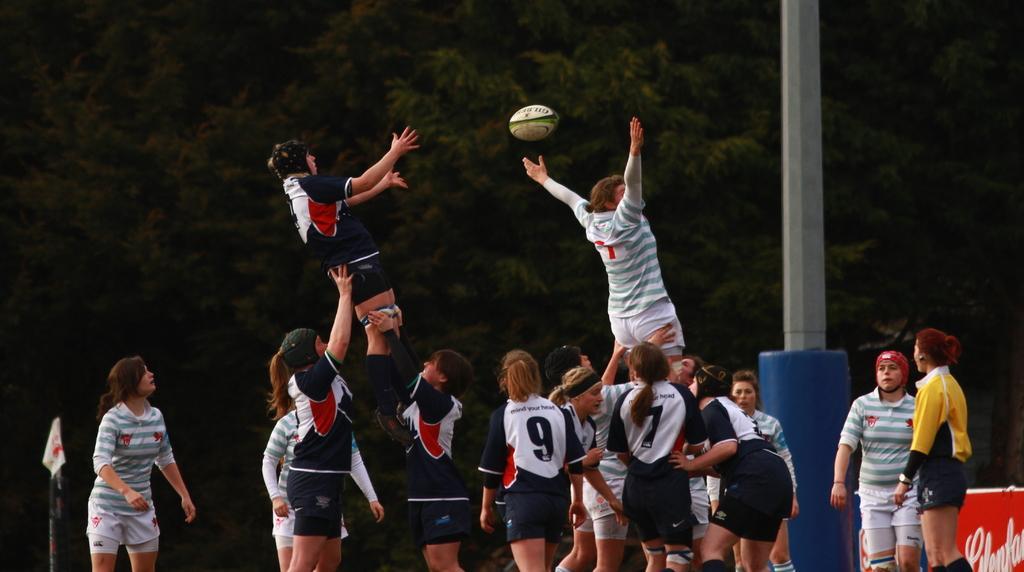Could you give a brief overview of what you see in this image? In this image, there are a few people. We can see some poles. Among them, we can see a pole with some cloth. We can also see a board with some text on the right. We can see a ball and some trees. 